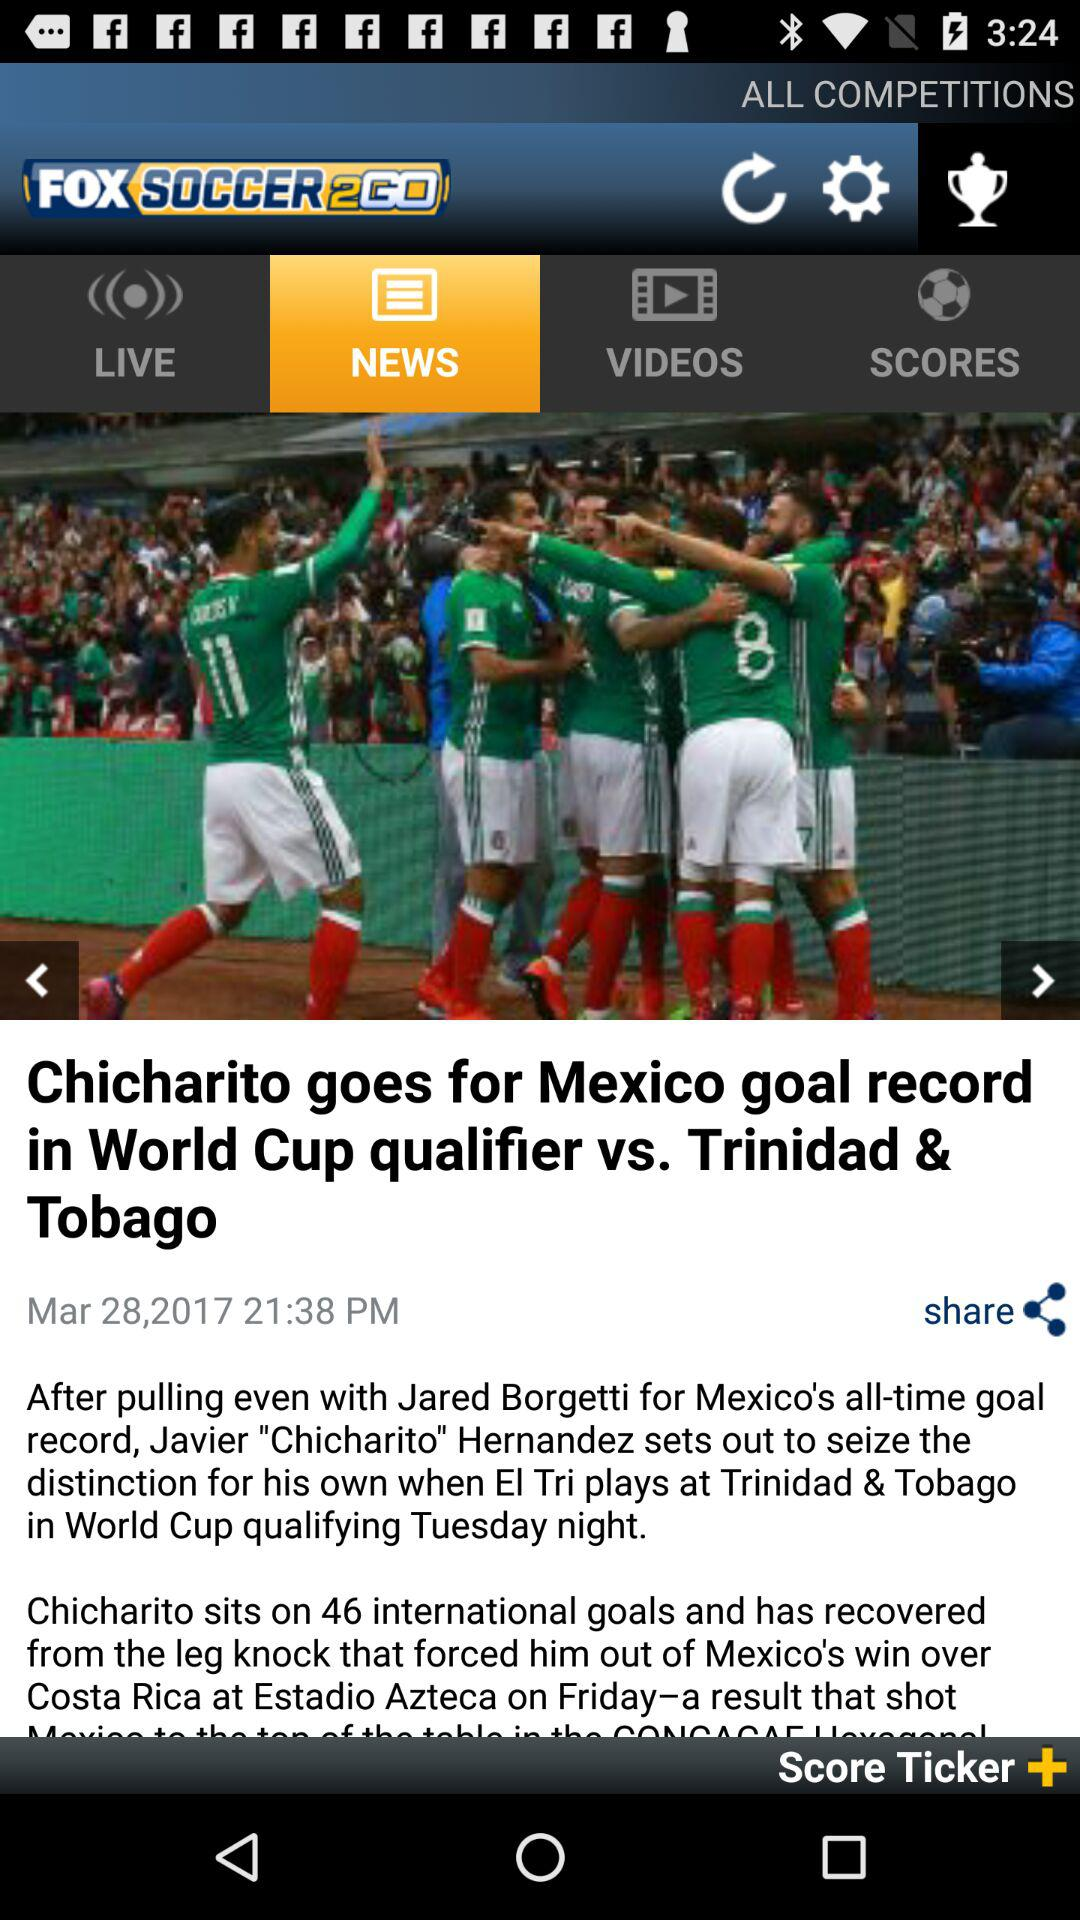What is the publication date of the article "Chicharito goes for Mexico goal record in world cup qualifier vs. Trinidad & Tobago? The publication date of the article is March 28, 2017. 